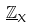<formula> <loc_0><loc_0><loc_500><loc_500>\underline { \mathbb { Z } } _ { X }</formula> 